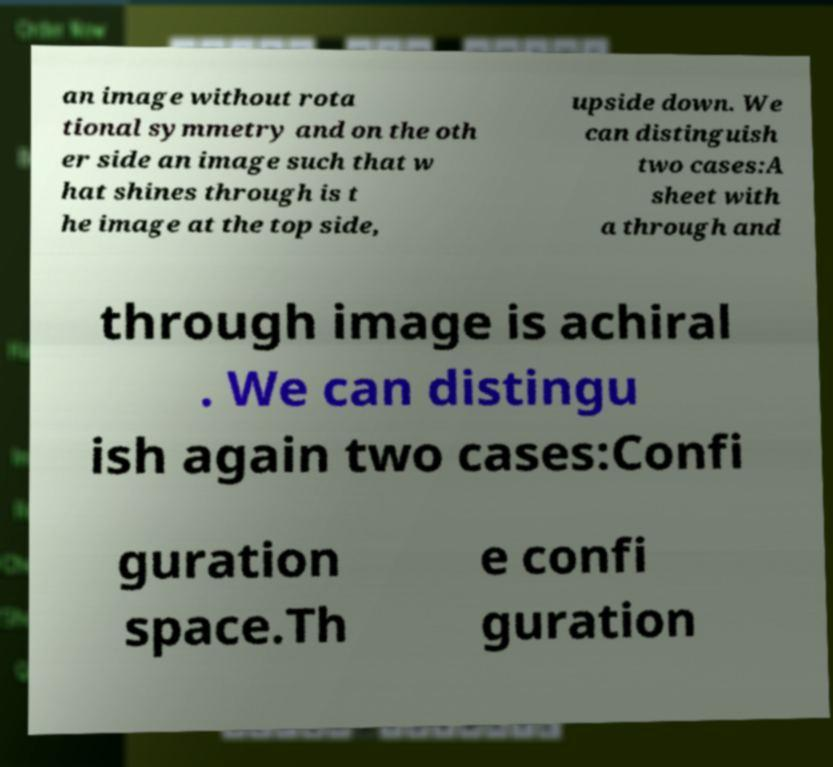Please identify and transcribe the text found in this image. an image without rota tional symmetry and on the oth er side an image such that w hat shines through is t he image at the top side, upside down. We can distinguish two cases:A sheet with a through and through image is achiral . We can distingu ish again two cases:Confi guration space.Th e confi guration 